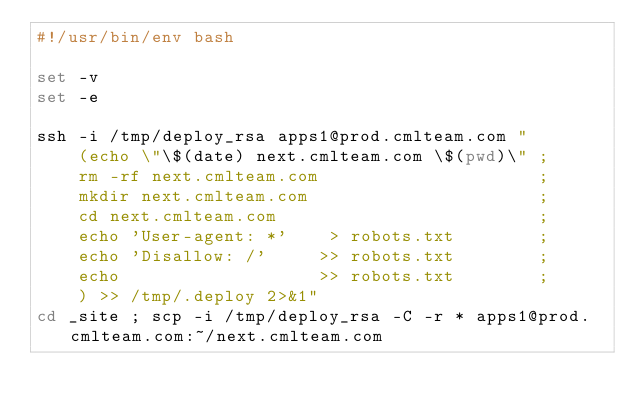<code> <loc_0><loc_0><loc_500><loc_500><_Bash_>#!/usr/bin/env bash

set -v
set -e

ssh -i /tmp/deploy_rsa apps1@prod.cmlteam.com "
    (echo \"\$(date) next.cmlteam.com \$(pwd)\" ;
    rm -rf next.cmlteam.com                     ;
    mkdir next.cmlteam.com                      ;
    cd next.cmlteam.com                         ;
    echo 'User-agent: *'    > robots.txt        ;
    echo 'Disallow: /'     >> robots.txt        ;
    echo                   >> robots.txt        ;
    ) >> /tmp/.deploy 2>&1"
cd _site ; scp -i /tmp/deploy_rsa -C -r * apps1@prod.cmlteam.com:~/next.cmlteam.com
</code> 